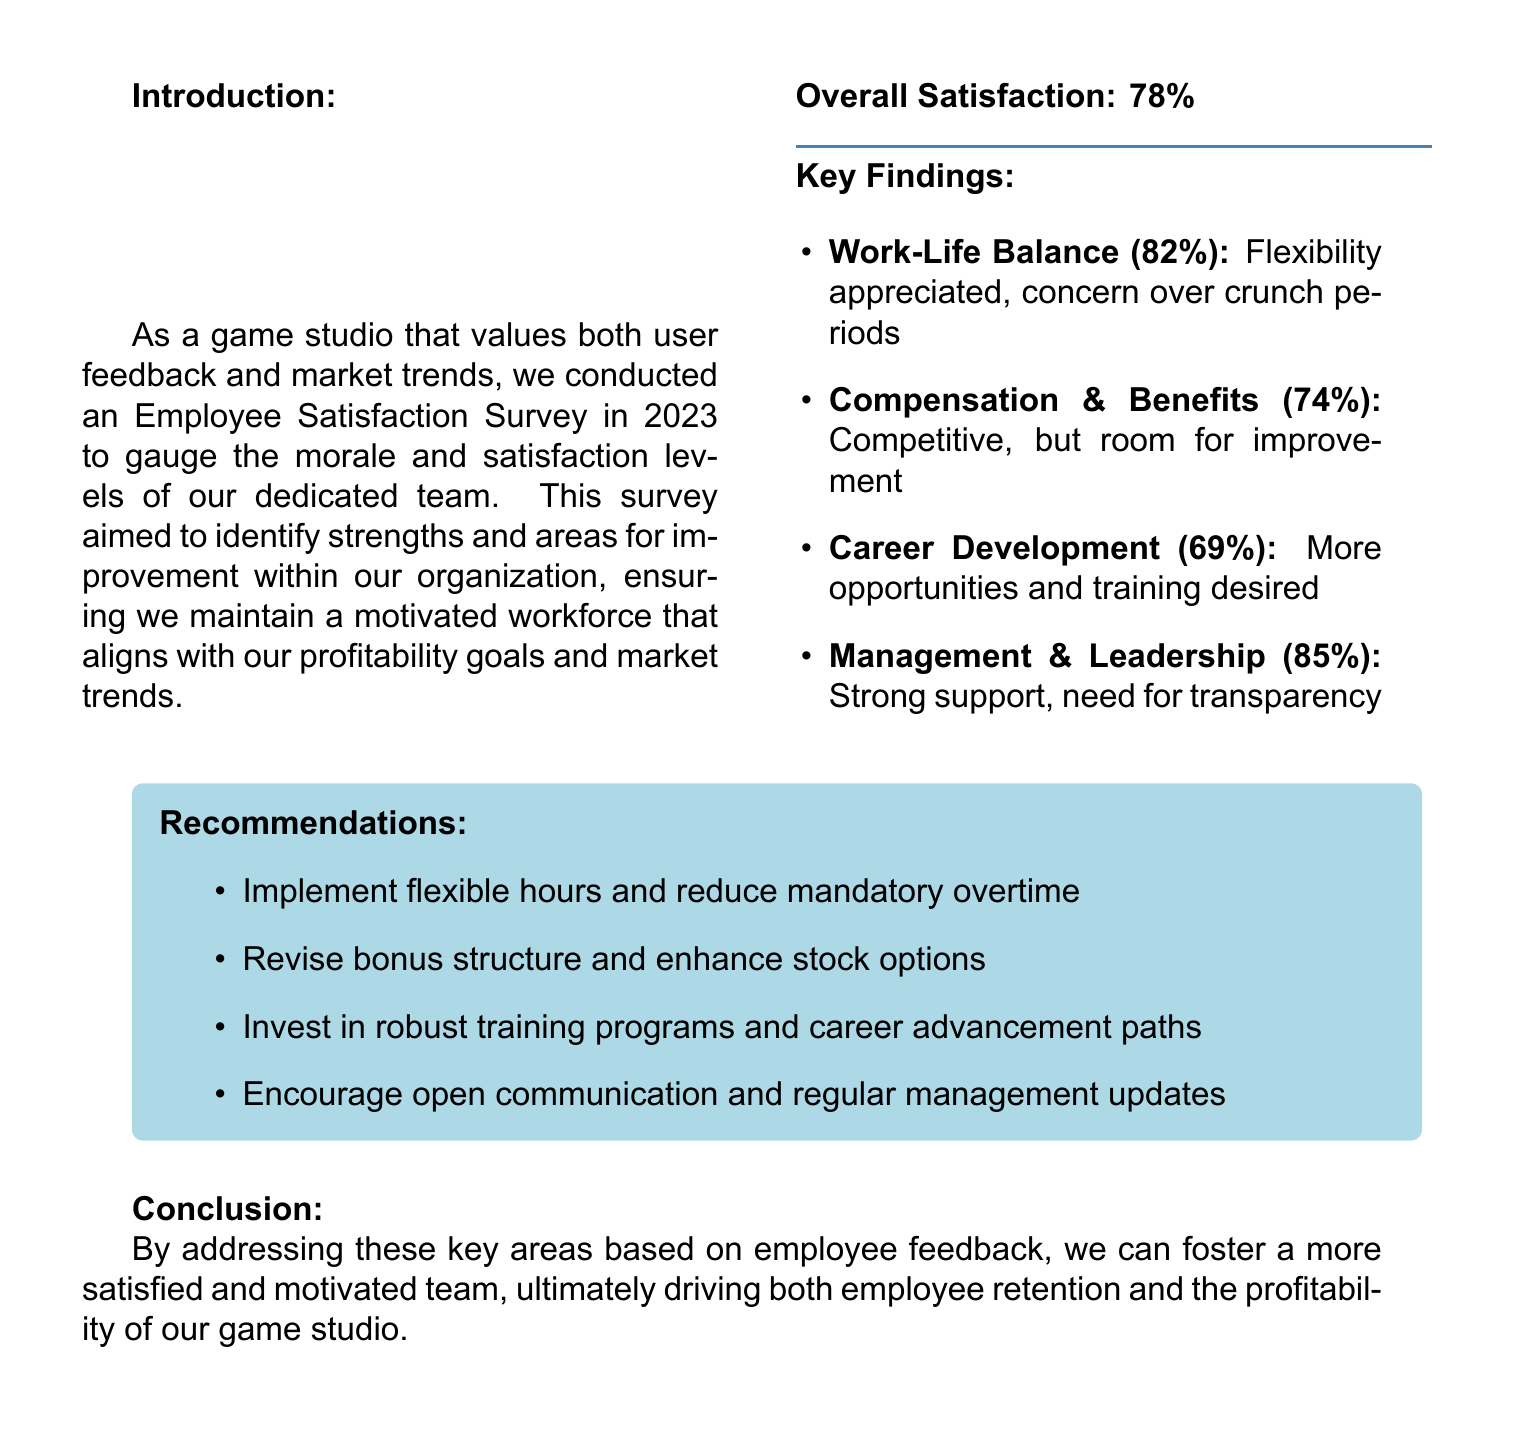what was the overall satisfaction percentage? The overall satisfaction percentage is presented in the document's key findings section.
Answer: 78% what percentage of employees appreciated work-life balance? The percentage of employees who appreciated work-life balance is listed under key findings.
Answer: 82% what area received the lowest satisfaction score? This is determined by comparing the satisfaction percentages of all areas mentioned.
Answer: Career Development what is one recommendation for improving work-life balance? The document suggests specific actions to address areas of concern, including work-life balance.
Answer: Implement flexible hours how many employees felt that compensation and benefits were competitive? The percentage indicating satisfaction with compensation and benefits is given in the key findings.
Answer: 74% which aspect of management received the highest satisfaction rating? This is found in the key findings section by looking for the highest percentage.
Answer: Management & Leadership what are employees looking for regarding career development? The document highlights specific desires expressed by employees concerning their career path.
Answer: More opportunities and training what color is used for the title background in the document? This can be identified by examining the visual style described in the document.
Answer: Gamestudio what does the introduction state is crucial for the game studio? The introduction outlines key values and goals for the organization.
Answer: User feedback 